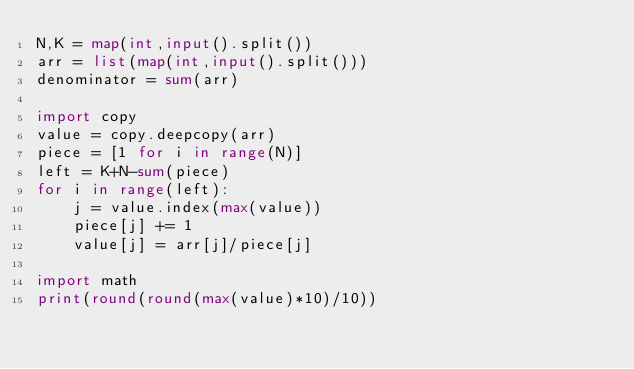<code> <loc_0><loc_0><loc_500><loc_500><_Python_>N,K = map(int,input().split())
arr = list(map(int,input().split()))
denominator = sum(arr)

import copy
value = copy.deepcopy(arr)
piece = [1 for i in range(N)]
left = K+N-sum(piece)
for i in range(left):
    j = value.index(max(value))
    piece[j] += 1
    value[j] = arr[j]/piece[j]

import math
print(round(round(max(value)*10)/10))</code> 